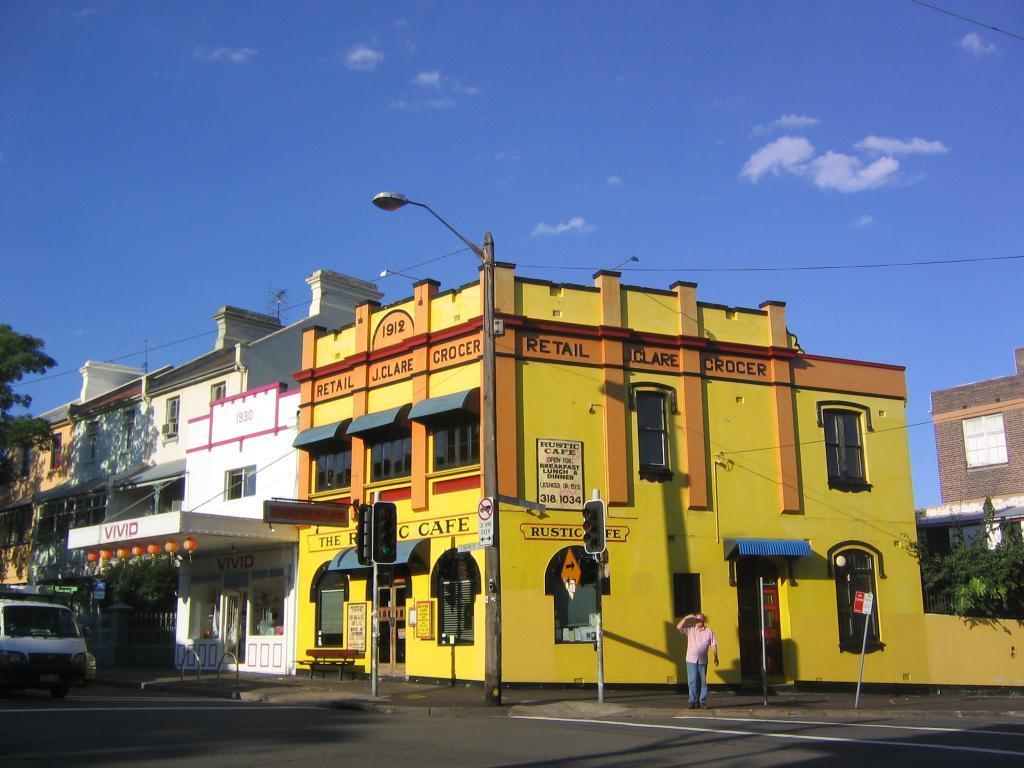Can you describe this image briefly? In this image we can see buildings. Image also consists of a light pole, two traffic signal light poles, a car and also tree. At the top there is sky with some clouds and at the bottom there is road. 